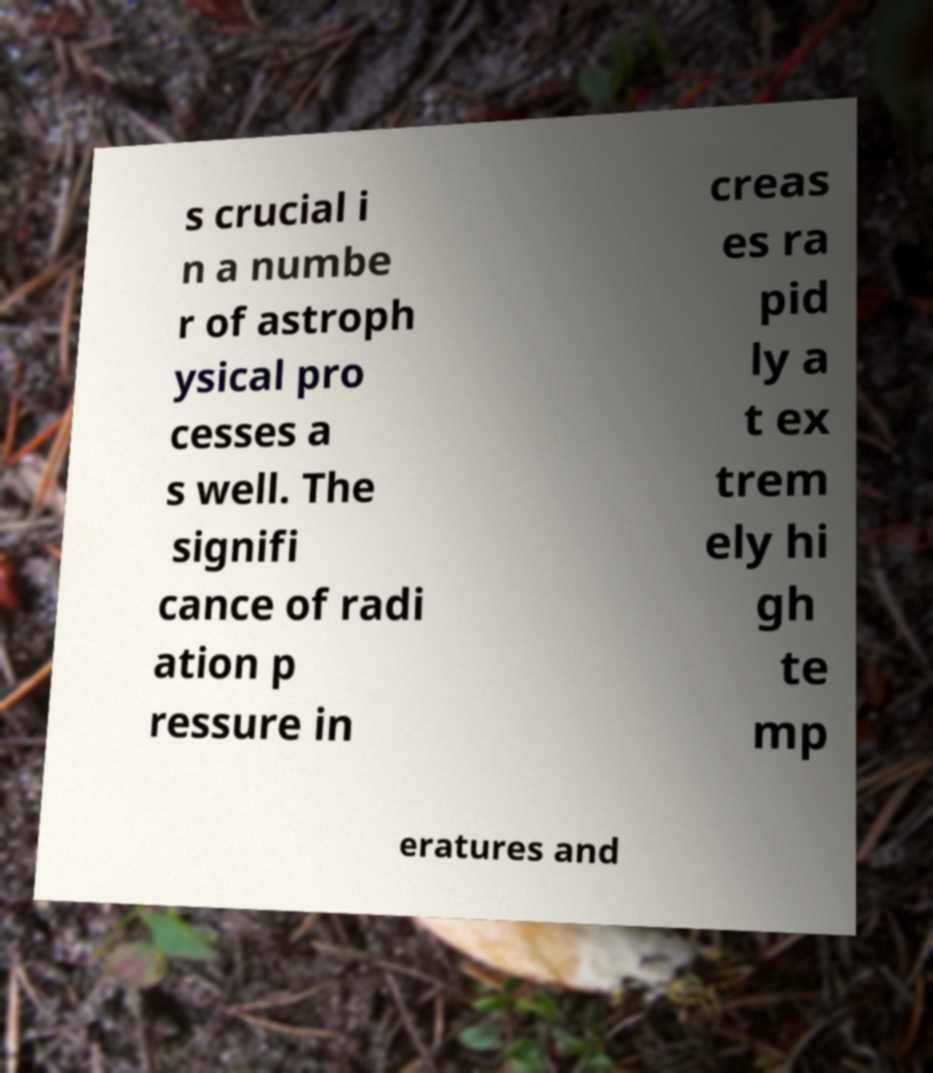Can you accurately transcribe the text from the provided image for me? s crucial i n a numbe r of astroph ysical pro cesses a s well. The signifi cance of radi ation p ressure in creas es ra pid ly a t ex trem ely hi gh te mp eratures and 